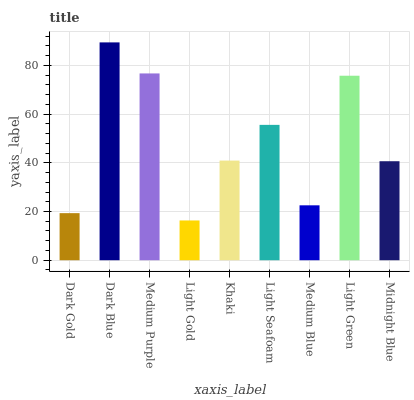Is Light Gold the minimum?
Answer yes or no. Yes. Is Dark Blue the maximum?
Answer yes or no. Yes. Is Medium Purple the minimum?
Answer yes or no. No. Is Medium Purple the maximum?
Answer yes or no. No. Is Dark Blue greater than Medium Purple?
Answer yes or no. Yes. Is Medium Purple less than Dark Blue?
Answer yes or no. Yes. Is Medium Purple greater than Dark Blue?
Answer yes or no. No. Is Dark Blue less than Medium Purple?
Answer yes or no. No. Is Khaki the high median?
Answer yes or no. Yes. Is Khaki the low median?
Answer yes or no. Yes. Is Medium Purple the high median?
Answer yes or no. No. Is Medium Purple the low median?
Answer yes or no. No. 